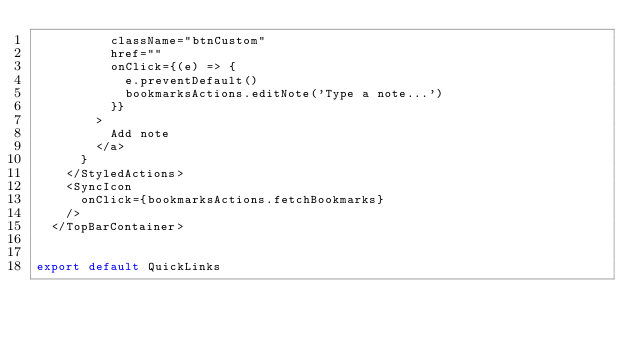Convert code to text. <code><loc_0><loc_0><loc_500><loc_500><_TypeScript_>          className="btnCustom"
          href=""
          onClick={(e) => {
            e.preventDefault()
            bookmarksActions.editNote('Type a note...')
          }}
        >
          Add note
        </a>
      }
    </StyledActions>
    <SyncIcon
      onClick={bookmarksActions.fetchBookmarks}
    />
  </TopBarContainer>


export default QuickLinks
</code> 